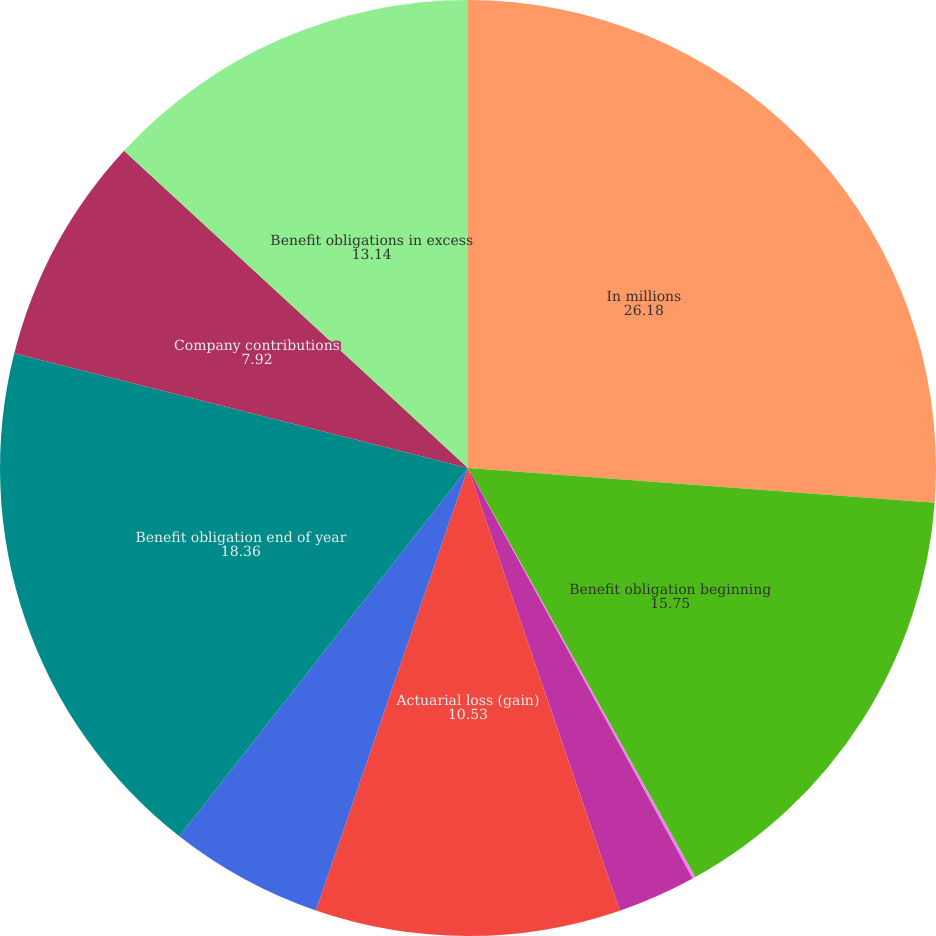<chart> <loc_0><loc_0><loc_500><loc_500><pie_chart><fcel>In millions<fcel>Benefit obligation beginning<fcel>Service cost<fcel>Interest cost<fcel>Actuarial loss (gain)<fcel>Benefits paid<fcel>Benefit obligation end of year<fcel>Company contributions<fcel>Benefit obligations in excess<nl><fcel>26.18%<fcel>15.75%<fcel>0.1%<fcel>2.71%<fcel>10.53%<fcel>5.31%<fcel>18.36%<fcel>7.92%<fcel>13.14%<nl></chart> 